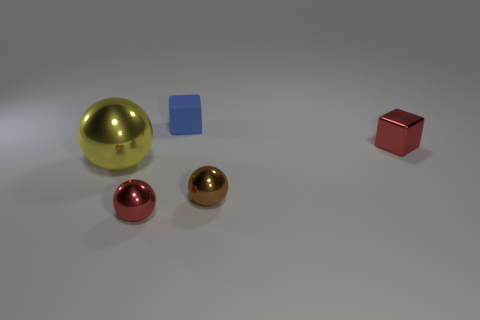What number of metal things are there?
Make the answer very short. 4. What number of blue things are blocks or large balls?
Make the answer very short. 1. How many other things are there of the same shape as the big yellow metallic object?
Keep it short and to the point. 2. Does the cube that is to the left of the tiny red block have the same color as the tiny metal object that is behind the brown thing?
Your answer should be compact. No. What number of large objects are purple matte cylinders or blue cubes?
Offer a terse response. 0. There is a red thing that is the same shape as the blue thing; what size is it?
Keep it short and to the point. Small. Is there any other thing that has the same size as the brown metal ball?
Provide a succinct answer. Yes. What material is the tiny sphere that is behind the red object in front of the big yellow ball?
Provide a succinct answer. Metal. What number of metallic objects are either brown objects or gray blocks?
Give a very brief answer. 1. There is another small metallic thing that is the same shape as the tiny brown metal object; what is its color?
Make the answer very short. Red. 